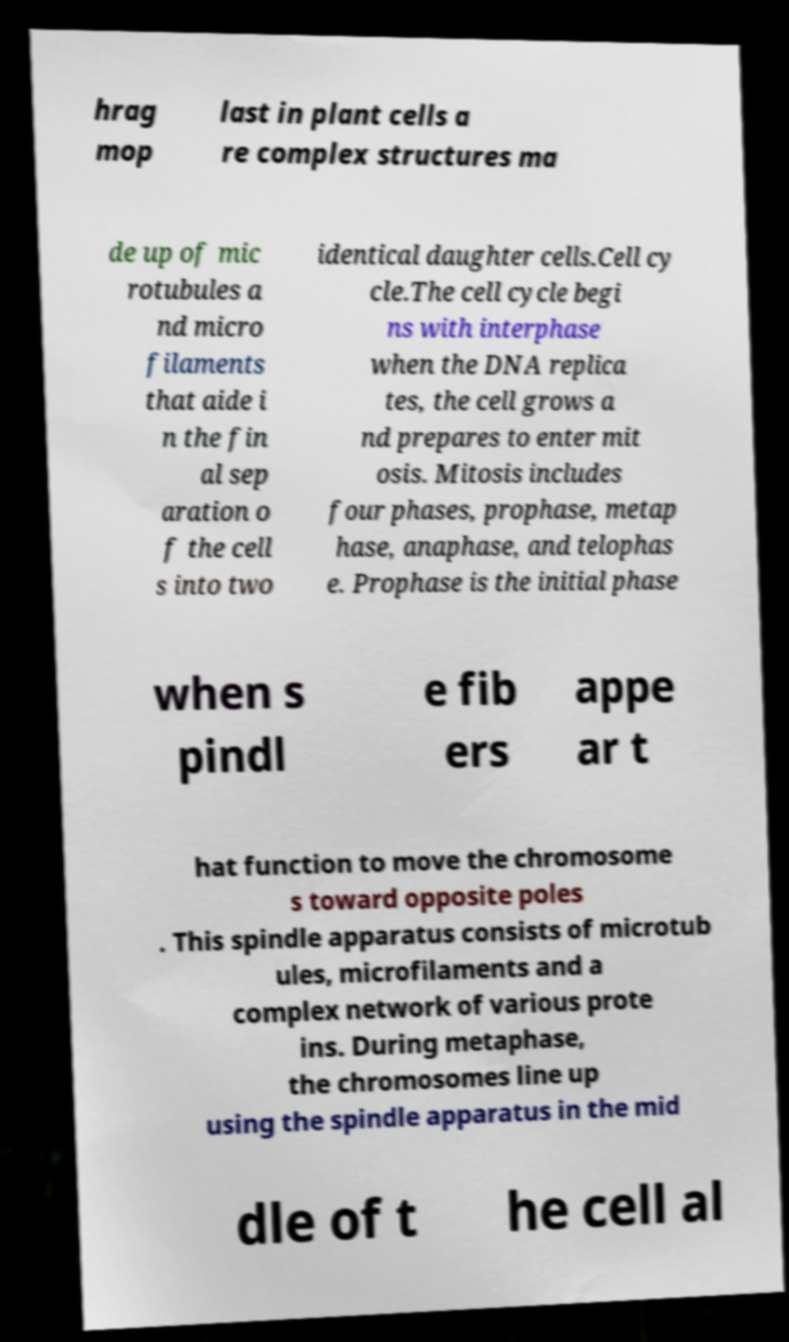Please identify and transcribe the text found in this image. hrag mop last in plant cells a re complex structures ma de up of mic rotubules a nd micro filaments that aide i n the fin al sep aration o f the cell s into two identical daughter cells.Cell cy cle.The cell cycle begi ns with interphase when the DNA replica tes, the cell grows a nd prepares to enter mit osis. Mitosis includes four phases, prophase, metap hase, anaphase, and telophas e. Prophase is the initial phase when s pindl e fib ers appe ar t hat function to move the chromosome s toward opposite poles . This spindle apparatus consists of microtub ules, microfilaments and a complex network of various prote ins. During metaphase, the chromosomes line up using the spindle apparatus in the mid dle of t he cell al 